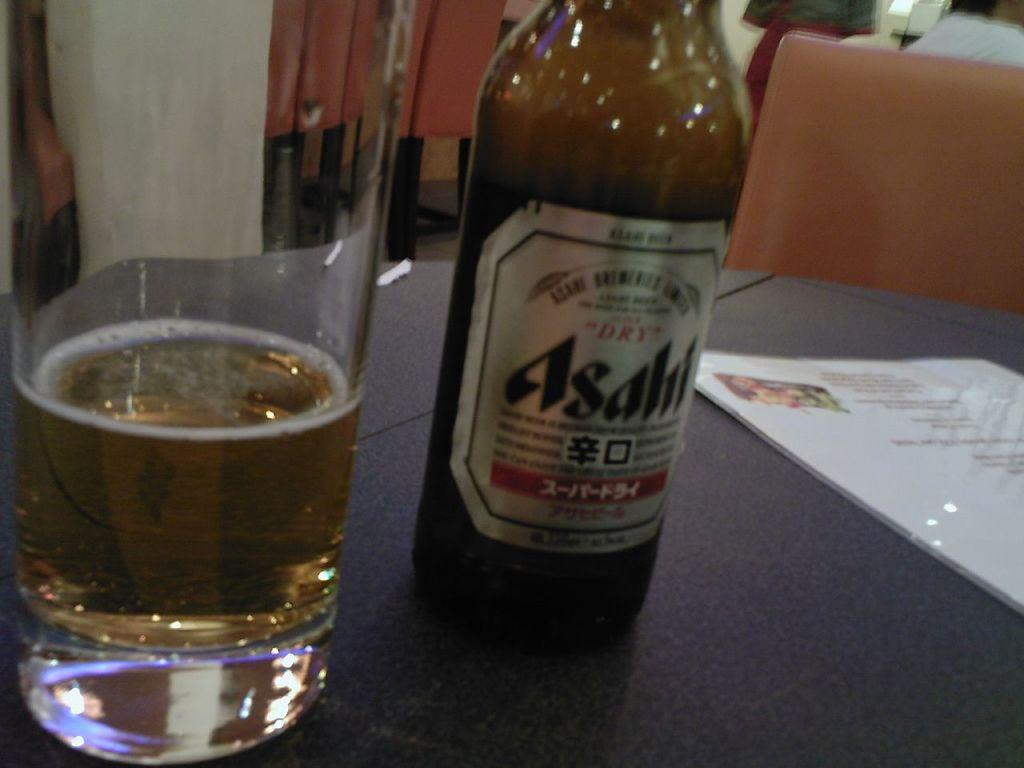<image>
Render a clear and concise summary of the photo. A bottle of Asahi beer is on a table next to a glass. 